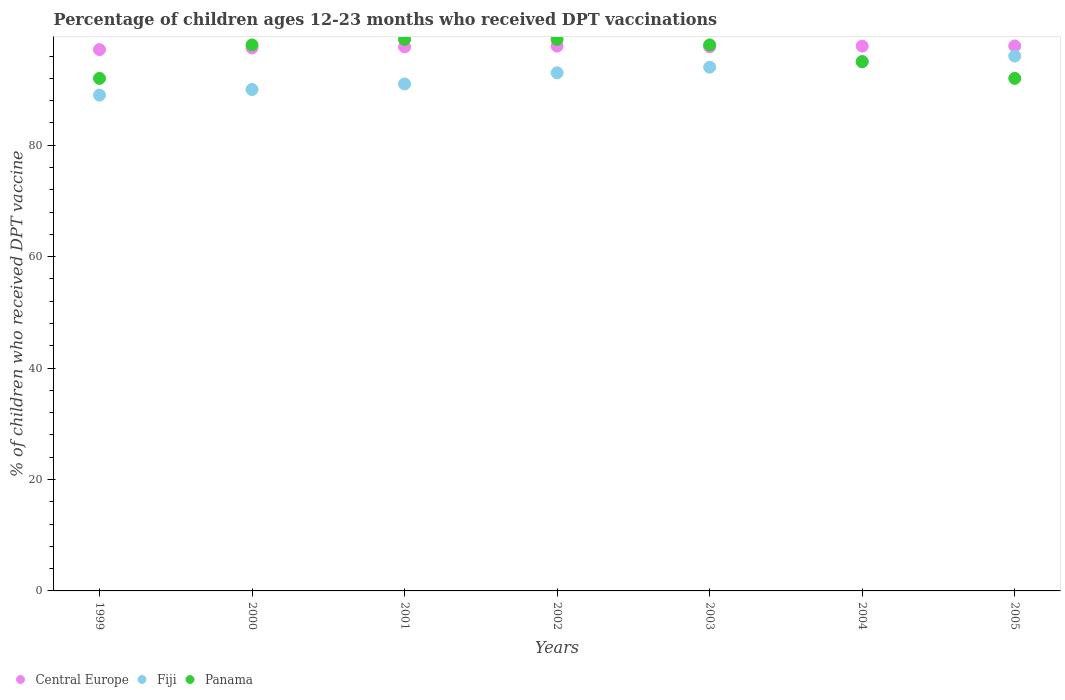How many different coloured dotlines are there?
Offer a terse response. 3. Is the number of dotlines equal to the number of legend labels?
Ensure brevity in your answer.  Yes. What is the percentage of children who received DPT vaccination in Panama in 2003?
Give a very brief answer. 98. Across all years, what is the maximum percentage of children who received DPT vaccination in Panama?
Your answer should be compact. 99. Across all years, what is the minimum percentage of children who received DPT vaccination in Panama?
Give a very brief answer. 92. In which year was the percentage of children who received DPT vaccination in Central Europe maximum?
Offer a terse response. 2005. In which year was the percentage of children who received DPT vaccination in Panama minimum?
Offer a very short reply. 1999. What is the total percentage of children who received DPT vaccination in Central Europe in the graph?
Provide a succinct answer. 683.32. What is the difference between the percentage of children who received DPT vaccination in Fiji in 2003 and that in 2005?
Offer a very short reply. -2. What is the difference between the percentage of children who received DPT vaccination in Panama in 2005 and the percentage of children who received DPT vaccination in Fiji in 2000?
Provide a short and direct response. 2. What is the average percentage of children who received DPT vaccination in Panama per year?
Give a very brief answer. 96.14. In the year 2002, what is the difference between the percentage of children who received DPT vaccination in Panama and percentage of children who received DPT vaccination in Fiji?
Your answer should be very brief. 6. What is the ratio of the percentage of children who received DPT vaccination in Central Europe in 1999 to that in 2004?
Your answer should be compact. 0.99. Is the percentage of children who received DPT vaccination in Panama in 2000 less than that in 2001?
Offer a very short reply. Yes. Is the difference between the percentage of children who received DPT vaccination in Panama in 2003 and 2004 greater than the difference between the percentage of children who received DPT vaccination in Fiji in 2003 and 2004?
Your answer should be compact. Yes. What is the difference between the highest and the lowest percentage of children who received DPT vaccination in Panama?
Ensure brevity in your answer.  7. Is the sum of the percentage of children who received DPT vaccination in Fiji in 2001 and 2004 greater than the maximum percentage of children who received DPT vaccination in Panama across all years?
Provide a short and direct response. Yes. Is it the case that in every year, the sum of the percentage of children who received DPT vaccination in Fiji and percentage of children who received DPT vaccination in Central Europe  is greater than the percentage of children who received DPT vaccination in Panama?
Your answer should be very brief. Yes. Does the percentage of children who received DPT vaccination in Panama monotonically increase over the years?
Ensure brevity in your answer.  No. How many dotlines are there?
Provide a short and direct response. 3. How many years are there in the graph?
Provide a short and direct response. 7. Are the values on the major ticks of Y-axis written in scientific E-notation?
Keep it short and to the point. No. Does the graph contain grids?
Offer a very short reply. No. How many legend labels are there?
Provide a short and direct response. 3. What is the title of the graph?
Give a very brief answer. Percentage of children ages 12-23 months who received DPT vaccinations. What is the label or title of the X-axis?
Your answer should be compact. Years. What is the label or title of the Y-axis?
Your answer should be very brief. % of children who received DPT vaccine. What is the % of children who received DPT vaccine of Central Europe in 1999?
Your answer should be very brief. 97.16. What is the % of children who received DPT vaccine in Fiji in 1999?
Offer a very short reply. 89. What is the % of children who received DPT vaccine of Panama in 1999?
Offer a terse response. 92. What is the % of children who received DPT vaccine of Central Europe in 2000?
Provide a short and direct response. 97.46. What is the % of children who received DPT vaccine of Fiji in 2000?
Offer a terse response. 90. What is the % of children who received DPT vaccine of Panama in 2000?
Keep it short and to the point. 98. What is the % of children who received DPT vaccine in Central Europe in 2001?
Make the answer very short. 97.65. What is the % of children who received DPT vaccine in Fiji in 2001?
Offer a terse response. 91. What is the % of children who received DPT vaccine of Central Europe in 2002?
Your answer should be very brief. 97.79. What is the % of children who received DPT vaccine of Fiji in 2002?
Keep it short and to the point. 93. What is the % of children who received DPT vaccine of Central Europe in 2003?
Offer a very short reply. 97.66. What is the % of children who received DPT vaccine in Fiji in 2003?
Your answer should be compact. 94. What is the % of children who received DPT vaccine of Panama in 2003?
Your answer should be compact. 98. What is the % of children who received DPT vaccine of Central Europe in 2004?
Make the answer very short. 97.79. What is the % of children who received DPT vaccine in Fiji in 2004?
Offer a terse response. 95. What is the % of children who received DPT vaccine in Central Europe in 2005?
Give a very brief answer. 97.81. What is the % of children who received DPT vaccine in Fiji in 2005?
Offer a terse response. 96. What is the % of children who received DPT vaccine in Panama in 2005?
Your answer should be compact. 92. Across all years, what is the maximum % of children who received DPT vaccine in Central Europe?
Make the answer very short. 97.81. Across all years, what is the maximum % of children who received DPT vaccine of Fiji?
Your answer should be very brief. 96. Across all years, what is the minimum % of children who received DPT vaccine in Central Europe?
Make the answer very short. 97.16. Across all years, what is the minimum % of children who received DPT vaccine of Fiji?
Your answer should be very brief. 89. Across all years, what is the minimum % of children who received DPT vaccine in Panama?
Provide a succinct answer. 92. What is the total % of children who received DPT vaccine in Central Europe in the graph?
Your answer should be compact. 683.32. What is the total % of children who received DPT vaccine of Fiji in the graph?
Provide a succinct answer. 648. What is the total % of children who received DPT vaccine in Panama in the graph?
Give a very brief answer. 673. What is the difference between the % of children who received DPT vaccine in Central Europe in 1999 and that in 2000?
Ensure brevity in your answer.  -0.3. What is the difference between the % of children who received DPT vaccine of Central Europe in 1999 and that in 2001?
Provide a succinct answer. -0.49. What is the difference between the % of children who received DPT vaccine in Fiji in 1999 and that in 2001?
Make the answer very short. -2. What is the difference between the % of children who received DPT vaccine in Panama in 1999 and that in 2001?
Give a very brief answer. -7. What is the difference between the % of children who received DPT vaccine in Central Europe in 1999 and that in 2002?
Offer a very short reply. -0.63. What is the difference between the % of children who received DPT vaccine of Panama in 1999 and that in 2002?
Your answer should be very brief. -7. What is the difference between the % of children who received DPT vaccine of Central Europe in 1999 and that in 2003?
Offer a terse response. -0.49. What is the difference between the % of children who received DPT vaccine in Fiji in 1999 and that in 2003?
Make the answer very short. -5. What is the difference between the % of children who received DPT vaccine in Panama in 1999 and that in 2003?
Ensure brevity in your answer.  -6. What is the difference between the % of children who received DPT vaccine of Central Europe in 1999 and that in 2004?
Your answer should be very brief. -0.62. What is the difference between the % of children who received DPT vaccine of Central Europe in 1999 and that in 2005?
Keep it short and to the point. -0.65. What is the difference between the % of children who received DPT vaccine of Central Europe in 2000 and that in 2001?
Your response must be concise. -0.19. What is the difference between the % of children who received DPT vaccine of Fiji in 2000 and that in 2001?
Ensure brevity in your answer.  -1. What is the difference between the % of children who received DPT vaccine in Central Europe in 2000 and that in 2002?
Give a very brief answer. -0.33. What is the difference between the % of children who received DPT vaccine in Fiji in 2000 and that in 2002?
Give a very brief answer. -3. What is the difference between the % of children who received DPT vaccine of Central Europe in 2000 and that in 2003?
Offer a very short reply. -0.19. What is the difference between the % of children who received DPT vaccine of Panama in 2000 and that in 2003?
Your response must be concise. 0. What is the difference between the % of children who received DPT vaccine of Central Europe in 2000 and that in 2004?
Keep it short and to the point. -0.32. What is the difference between the % of children who received DPT vaccine in Fiji in 2000 and that in 2004?
Make the answer very short. -5. What is the difference between the % of children who received DPT vaccine in Central Europe in 2000 and that in 2005?
Your answer should be compact. -0.35. What is the difference between the % of children who received DPT vaccine of Fiji in 2000 and that in 2005?
Offer a very short reply. -6. What is the difference between the % of children who received DPT vaccine in Central Europe in 2001 and that in 2002?
Make the answer very short. -0.14. What is the difference between the % of children who received DPT vaccine in Fiji in 2001 and that in 2002?
Your answer should be compact. -2. What is the difference between the % of children who received DPT vaccine in Panama in 2001 and that in 2002?
Ensure brevity in your answer.  0. What is the difference between the % of children who received DPT vaccine of Central Europe in 2001 and that in 2003?
Your answer should be very brief. -0.01. What is the difference between the % of children who received DPT vaccine of Central Europe in 2001 and that in 2004?
Your response must be concise. -0.13. What is the difference between the % of children who received DPT vaccine of Fiji in 2001 and that in 2004?
Offer a very short reply. -4. What is the difference between the % of children who received DPT vaccine of Panama in 2001 and that in 2004?
Ensure brevity in your answer.  4. What is the difference between the % of children who received DPT vaccine in Central Europe in 2001 and that in 2005?
Offer a terse response. -0.16. What is the difference between the % of children who received DPT vaccine of Fiji in 2001 and that in 2005?
Keep it short and to the point. -5. What is the difference between the % of children who received DPT vaccine in Central Europe in 2002 and that in 2003?
Offer a terse response. 0.13. What is the difference between the % of children who received DPT vaccine in Fiji in 2002 and that in 2003?
Provide a succinct answer. -1. What is the difference between the % of children who received DPT vaccine in Central Europe in 2002 and that in 2004?
Ensure brevity in your answer.  0.01. What is the difference between the % of children who received DPT vaccine of Fiji in 2002 and that in 2004?
Your response must be concise. -2. What is the difference between the % of children who received DPT vaccine in Panama in 2002 and that in 2004?
Keep it short and to the point. 4. What is the difference between the % of children who received DPT vaccine of Central Europe in 2002 and that in 2005?
Your answer should be very brief. -0.02. What is the difference between the % of children who received DPT vaccine of Fiji in 2002 and that in 2005?
Make the answer very short. -3. What is the difference between the % of children who received DPT vaccine of Panama in 2002 and that in 2005?
Your answer should be very brief. 7. What is the difference between the % of children who received DPT vaccine in Central Europe in 2003 and that in 2004?
Give a very brief answer. -0.13. What is the difference between the % of children who received DPT vaccine of Fiji in 2003 and that in 2004?
Offer a terse response. -1. What is the difference between the % of children who received DPT vaccine in Panama in 2003 and that in 2004?
Keep it short and to the point. 3. What is the difference between the % of children who received DPT vaccine of Central Europe in 2003 and that in 2005?
Your response must be concise. -0.15. What is the difference between the % of children who received DPT vaccine in Fiji in 2003 and that in 2005?
Make the answer very short. -2. What is the difference between the % of children who received DPT vaccine of Panama in 2003 and that in 2005?
Make the answer very short. 6. What is the difference between the % of children who received DPT vaccine in Central Europe in 2004 and that in 2005?
Your response must be concise. -0.02. What is the difference between the % of children who received DPT vaccine in Fiji in 2004 and that in 2005?
Keep it short and to the point. -1. What is the difference between the % of children who received DPT vaccine in Central Europe in 1999 and the % of children who received DPT vaccine in Fiji in 2000?
Keep it short and to the point. 7.16. What is the difference between the % of children who received DPT vaccine of Central Europe in 1999 and the % of children who received DPT vaccine of Panama in 2000?
Provide a succinct answer. -0.84. What is the difference between the % of children who received DPT vaccine of Fiji in 1999 and the % of children who received DPT vaccine of Panama in 2000?
Your response must be concise. -9. What is the difference between the % of children who received DPT vaccine in Central Europe in 1999 and the % of children who received DPT vaccine in Fiji in 2001?
Your answer should be compact. 6.16. What is the difference between the % of children who received DPT vaccine of Central Europe in 1999 and the % of children who received DPT vaccine of Panama in 2001?
Offer a very short reply. -1.84. What is the difference between the % of children who received DPT vaccine in Central Europe in 1999 and the % of children who received DPT vaccine in Fiji in 2002?
Ensure brevity in your answer.  4.16. What is the difference between the % of children who received DPT vaccine in Central Europe in 1999 and the % of children who received DPT vaccine in Panama in 2002?
Give a very brief answer. -1.84. What is the difference between the % of children who received DPT vaccine in Fiji in 1999 and the % of children who received DPT vaccine in Panama in 2002?
Your answer should be compact. -10. What is the difference between the % of children who received DPT vaccine in Central Europe in 1999 and the % of children who received DPT vaccine in Fiji in 2003?
Your answer should be compact. 3.16. What is the difference between the % of children who received DPT vaccine in Central Europe in 1999 and the % of children who received DPT vaccine in Panama in 2003?
Offer a terse response. -0.84. What is the difference between the % of children who received DPT vaccine in Central Europe in 1999 and the % of children who received DPT vaccine in Fiji in 2004?
Ensure brevity in your answer.  2.16. What is the difference between the % of children who received DPT vaccine of Central Europe in 1999 and the % of children who received DPT vaccine of Panama in 2004?
Your answer should be compact. 2.16. What is the difference between the % of children who received DPT vaccine of Fiji in 1999 and the % of children who received DPT vaccine of Panama in 2004?
Keep it short and to the point. -6. What is the difference between the % of children who received DPT vaccine in Central Europe in 1999 and the % of children who received DPT vaccine in Fiji in 2005?
Offer a very short reply. 1.16. What is the difference between the % of children who received DPT vaccine of Central Europe in 1999 and the % of children who received DPT vaccine of Panama in 2005?
Offer a terse response. 5.16. What is the difference between the % of children who received DPT vaccine of Fiji in 1999 and the % of children who received DPT vaccine of Panama in 2005?
Offer a very short reply. -3. What is the difference between the % of children who received DPT vaccine of Central Europe in 2000 and the % of children who received DPT vaccine of Fiji in 2001?
Your response must be concise. 6.46. What is the difference between the % of children who received DPT vaccine in Central Europe in 2000 and the % of children who received DPT vaccine in Panama in 2001?
Your answer should be compact. -1.54. What is the difference between the % of children who received DPT vaccine of Fiji in 2000 and the % of children who received DPT vaccine of Panama in 2001?
Provide a succinct answer. -9. What is the difference between the % of children who received DPT vaccine of Central Europe in 2000 and the % of children who received DPT vaccine of Fiji in 2002?
Provide a succinct answer. 4.46. What is the difference between the % of children who received DPT vaccine in Central Europe in 2000 and the % of children who received DPT vaccine in Panama in 2002?
Ensure brevity in your answer.  -1.54. What is the difference between the % of children who received DPT vaccine in Central Europe in 2000 and the % of children who received DPT vaccine in Fiji in 2003?
Provide a short and direct response. 3.46. What is the difference between the % of children who received DPT vaccine of Central Europe in 2000 and the % of children who received DPT vaccine of Panama in 2003?
Your response must be concise. -0.54. What is the difference between the % of children who received DPT vaccine in Central Europe in 2000 and the % of children who received DPT vaccine in Fiji in 2004?
Your response must be concise. 2.46. What is the difference between the % of children who received DPT vaccine of Central Europe in 2000 and the % of children who received DPT vaccine of Panama in 2004?
Give a very brief answer. 2.46. What is the difference between the % of children who received DPT vaccine of Fiji in 2000 and the % of children who received DPT vaccine of Panama in 2004?
Provide a short and direct response. -5. What is the difference between the % of children who received DPT vaccine of Central Europe in 2000 and the % of children who received DPT vaccine of Fiji in 2005?
Give a very brief answer. 1.46. What is the difference between the % of children who received DPT vaccine of Central Europe in 2000 and the % of children who received DPT vaccine of Panama in 2005?
Ensure brevity in your answer.  5.46. What is the difference between the % of children who received DPT vaccine in Central Europe in 2001 and the % of children who received DPT vaccine in Fiji in 2002?
Offer a terse response. 4.65. What is the difference between the % of children who received DPT vaccine of Central Europe in 2001 and the % of children who received DPT vaccine of Panama in 2002?
Provide a succinct answer. -1.35. What is the difference between the % of children who received DPT vaccine of Central Europe in 2001 and the % of children who received DPT vaccine of Fiji in 2003?
Your answer should be compact. 3.65. What is the difference between the % of children who received DPT vaccine in Central Europe in 2001 and the % of children who received DPT vaccine in Panama in 2003?
Provide a short and direct response. -0.35. What is the difference between the % of children who received DPT vaccine of Central Europe in 2001 and the % of children who received DPT vaccine of Fiji in 2004?
Your response must be concise. 2.65. What is the difference between the % of children who received DPT vaccine in Central Europe in 2001 and the % of children who received DPT vaccine in Panama in 2004?
Your answer should be compact. 2.65. What is the difference between the % of children who received DPT vaccine in Central Europe in 2001 and the % of children who received DPT vaccine in Fiji in 2005?
Make the answer very short. 1.65. What is the difference between the % of children who received DPT vaccine in Central Europe in 2001 and the % of children who received DPT vaccine in Panama in 2005?
Your answer should be compact. 5.65. What is the difference between the % of children who received DPT vaccine in Fiji in 2001 and the % of children who received DPT vaccine in Panama in 2005?
Keep it short and to the point. -1. What is the difference between the % of children who received DPT vaccine of Central Europe in 2002 and the % of children who received DPT vaccine of Fiji in 2003?
Provide a short and direct response. 3.79. What is the difference between the % of children who received DPT vaccine in Central Europe in 2002 and the % of children who received DPT vaccine in Panama in 2003?
Keep it short and to the point. -0.21. What is the difference between the % of children who received DPT vaccine in Fiji in 2002 and the % of children who received DPT vaccine in Panama in 2003?
Give a very brief answer. -5. What is the difference between the % of children who received DPT vaccine in Central Europe in 2002 and the % of children who received DPT vaccine in Fiji in 2004?
Offer a terse response. 2.79. What is the difference between the % of children who received DPT vaccine of Central Europe in 2002 and the % of children who received DPT vaccine of Panama in 2004?
Ensure brevity in your answer.  2.79. What is the difference between the % of children who received DPT vaccine of Central Europe in 2002 and the % of children who received DPT vaccine of Fiji in 2005?
Your answer should be very brief. 1.79. What is the difference between the % of children who received DPT vaccine in Central Europe in 2002 and the % of children who received DPT vaccine in Panama in 2005?
Your answer should be compact. 5.79. What is the difference between the % of children who received DPT vaccine in Fiji in 2002 and the % of children who received DPT vaccine in Panama in 2005?
Keep it short and to the point. 1. What is the difference between the % of children who received DPT vaccine in Central Europe in 2003 and the % of children who received DPT vaccine in Fiji in 2004?
Keep it short and to the point. 2.66. What is the difference between the % of children who received DPT vaccine in Central Europe in 2003 and the % of children who received DPT vaccine in Panama in 2004?
Give a very brief answer. 2.66. What is the difference between the % of children who received DPT vaccine in Central Europe in 2003 and the % of children who received DPT vaccine in Fiji in 2005?
Provide a short and direct response. 1.66. What is the difference between the % of children who received DPT vaccine in Central Europe in 2003 and the % of children who received DPT vaccine in Panama in 2005?
Your answer should be compact. 5.66. What is the difference between the % of children who received DPT vaccine in Central Europe in 2004 and the % of children who received DPT vaccine in Fiji in 2005?
Provide a succinct answer. 1.79. What is the difference between the % of children who received DPT vaccine of Central Europe in 2004 and the % of children who received DPT vaccine of Panama in 2005?
Offer a very short reply. 5.79. What is the difference between the % of children who received DPT vaccine of Fiji in 2004 and the % of children who received DPT vaccine of Panama in 2005?
Your response must be concise. 3. What is the average % of children who received DPT vaccine in Central Europe per year?
Make the answer very short. 97.62. What is the average % of children who received DPT vaccine of Fiji per year?
Your answer should be very brief. 92.57. What is the average % of children who received DPT vaccine of Panama per year?
Ensure brevity in your answer.  96.14. In the year 1999, what is the difference between the % of children who received DPT vaccine of Central Europe and % of children who received DPT vaccine of Fiji?
Offer a terse response. 8.16. In the year 1999, what is the difference between the % of children who received DPT vaccine of Central Europe and % of children who received DPT vaccine of Panama?
Provide a short and direct response. 5.16. In the year 1999, what is the difference between the % of children who received DPT vaccine in Fiji and % of children who received DPT vaccine in Panama?
Your response must be concise. -3. In the year 2000, what is the difference between the % of children who received DPT vaccine of Central Europe and % of children who received DPT vaccine of Fiji?
Keep it short and to the point. 7.46. In the year 2000, what is the difference between the % of children who received DPT vaccine of Central Europe and % of children who received DPT vaccine of Panama?
Keep it short and to the point. -0.54. In the year 2000, what is the difference between the % of children who received DPT vaccine in Fiji and % of children who received DPT vaccine in Panama?
Make the answer very short. -8. In the year 2001, what is the difference between the % of children who received DPT vaccine in Central Europe and % of children who received DPT vaccine in Fiji?
Make the answer very short. 6.65. In the year 2001, what is the difference between the % of children who received DPT vaccine in Central Europe and % of children who received DPT vaccine in Panama?
Offer a very short reply. -1.35. In the year 2002, what is the difference between the % of children who received DPT vaccine of Central Europe and % of children who received DPT vaccine of Fiji?
Your answer should be compact. 4.79. In the year 2002, what is the difference between the % of children who received DPT vaccine of Central Europe and % of children who received DPT vaccine of Panama?
Offer a very short reply. -1.21. In the year 2002, what is the difference between the % of children who received DPT vaccine in Fiji and % of children who received DPT vaccine in Panama?
Your answer should be compact. -6. In the year 2003, what is the difference between the % of children who received DPT vaccine in Central Europe and % of children who received DPT vaccine in Fiji?
Ensure brevity in your answer.  3.66. In the year 2003, what is the difference between the % of children who received DPT vaccine of Central Europe and % of children who received DPT vaccine of Panama?
Keep it short and to the point. -0.34. In the year 2004, what is the difference between the % of children who received DPT vaccine in Central Europe and % of children who received DPT vaccine in Fiji?
Provide a succinct answer. 2.79. In the year 2004, what is the difference between the % of children who received DPT vaccine in Central Europe and % of children who received DPT vaccine in Panama?
Ensure brevity in your answer.  2.79. In the year 2004, what is the difference between the % of children who received DPT vaccine in Fiji and % of children who received DPT vaccine in Panama?
Your answer should be very brief. 0. In the year 2005, what is the difference between the % of children who received DPT vaccine of Central Europe and % of children who received DPT vaccine of Fiji?
Ensure brevity in your answer.  1.81. In the year 2005, what is the difference between the % of children who received DPT vaccine of Central Europe and % of children who received DPT vaccine of Panama?
Keep it short and to the point. 5.81. What is the ratio of the % of children who received DPT vaccine of Central Europe in 1999 to that in 2000?
Offer a very short reply. 1. What is the ratio of the % of children who received DPT vaccine of Fiji in 1999 to that in 2000?
Your response must be concise. 0.99. What is the ratio of the % of children who received DPT vaccine of Panama in 1999 to that in 2000?
Offer a very short reply. 0.94. What is the ratio of the % of children who received DPT vaccine of Fiji in 1999 to that in 2001?
Your response must be concise. 0.98. What is the ratio of the % of children who received DPT vaccine in Panama in 1999 to that in 2001?
Keep it short and to the point. 0.93. What is the ratio of the % of children who received DPT vaccine in Panama in 1999 to that in 2002?
Provide a succinct answer. 0.93. What is the ratio of the % of children who received DPT vaccine in Central Europe in 1999 to that in 2003?
Ensure brevity in your answer.  0.99. What is the ratio of the % of children who received DPT vaccine in Fiji in 1999 to that in 2003?
Your answer should be very brief. 0.95. What is the ratio of the % of children who received DPT vaccine in Panama in 1999 to that in 2003?
Your response must be concise. 0.94. What is the ratio of the % of children who received DPT vaccine of Central Europe in 1999 to that in 2004?
Offer a very short reply. 0.99. What is the ratio of the % of children who received DPT vaccine in Fiji in 1999 to that in 2004?
Make the answer very short. 0.94. What is the ratio of the % of children who received DPT vaccine of Panama in 1999 to that in 2004?
Ensure brevity in your answer.  0.97. What is the ratio of the % of children who received DPT vaccine in Central Europe in 1999 to that in 2005?
Provide a short and direct response. 0.99. What is the ratio of the % of children who received DPT vaccine in Fiji in 1999 to that in 2005?
Your response must be concise. 0.93. What is the ratio of the % of children who received DPT vaccine of Central Europe in 2000 to that in 2001?
Give a very brief answer. 1. What is the ratio of the % of children who received DPT vaccine in Fiji in 2000 to that in 2001?
Offer a very short reply. 0.99. What is the ratio of the % of children who received DPT vaccine in Central Europe in 2000 to that in 2002?
Keep it short and to the point. 1. What is the ratio of the % of children who received DPT vaccine of Panama in 2000 to that in 2002?
Provide a succinct answer. 0.99. What is the ratio of the % of children who received DPT vaccine in Central Europe in 2000 to that in 2003?
Your response must be concise. 1. What is the ratio of the % of children who received DPT vaccine in Fiji in 2000 to that in 2003?
Ensure brevity in your answer.  0.96. What is the ratio of the % of children who received DPT vaccine in Panama in 2000 to that in 2003?
Keep it short and to the point. 1. What is the ratio of the % of children who received DPT vaccine of Central Europe in 2000 to that in 2004?
Provide a succinct answer. 1. What is the ratio of the % of children who received DPT vaccine of Panama in 2000 to that in 2004?
Make the answer very short. 1.03. What is the ratio of the % of children who received DPT vaccine of Fiji in 2000 to that in 2005?
Keep it short and to the point. 0.94. What is the ratio of the % of children who received DPT vaccine of Panama in 2000 to that in 2005?
Keep it short and to the point. 1.07. What is the ratio of the % of children who received DPT vaccine of Fiji in 2001 to that in 2002?
Provide a short and direct response. 0.98. What is the ratio of the % of children who received DPT vaccine of Central Europe in 2001 to that in 2003?
Provide a succinct answer. 1. What is the ratio of the % of children who received DPT vaccine of Fiji in 2001 to that in 2003?
Your answer should be very brief. 0.97. What is the ratio of the % of children who received DPT vaccine in Panama in 2001 to that in 2003?
Your answer should be very brief. 1.01. What is the ratio of the % of children who received DPT vaccine in Fiji in 2001 to that in 2004?
Keep it short and to the point. 0.96. What is the ratio of the % of children who received DPT vaccine of Panama in 2001 to that in 2004?
Make the answer very short. 1.04. What is the ratio of the % of children who received DPT vaccine of Central Europe in 2001 to that in 2005?
Your answer should be very brief. 1. What is the ratio of the % of children who received DPT vaccine in Fiji in 2001 to that in 2005?
Ensure brevity in your answer.  0.95. What is the ratio of the % of children who received DPT vaccine of Panama in 2001 to that in 2005?
Your response must be concise. 1.08. What is the ratio of the % of children who received DPT vaccine in Fiji in 2002 to that in 2003?
Make the answer very short. 0.99. What is the ratio of the % of children who received DPT vaccine of Panama in 2002 to that in 2003?
Offer a terse response. 1.01. What is the ratio of the % of children who received DPT vaccine of Central Europe in 2002 to that in 2004?
Ensure brevity in your answer.  1. What is the ratio of the % of children who received DPT vaccine in Fiji in 2002 to that in 2004?
Give a very brief answer. 0.98. What is the ratio of the % of children who received DPT vaccine in Panama in 2002 to that in 2004?
Offer a very short reply. 1.04. What is the ratio of the % of children who received DPT vaccine in Fiji in 2002 to that in 2005?
Provide a short and direct response. 0.97. What is the ratio of the % of children who received DPT vaccine of Panama in 2002 to that in 2005?
Give a very brief answer. 1.08. What is the ratio of the % of children who received DPT vaccine of Fiji in 2003 to that in 2004?
Offer a very short reply. 0.99. What is the ratio of the % of children who received DPT vaccine in Panama in 2003 to that in 2004?
Offer a terse response. 1.03. What is the ratio of the % of children who received DPT vaccine of Fiji in 2003 to that in 2005?
Ensure brevity in your answer.  0.98. What is the ratio of the % of children who received DPT vaccine in Panama in 2003 to that in 2005?
Keep it short and to the point. 1.07. What is the ratio of the % of children who received DPT vaccine in Central Europe in 2004 to that in 2005?
Offer a terse response. 1. What is the ratio of the % of children who received DPT vaccine in Fiji in 2004 to that in 2005?
Your answer should be compact. 0.99. What is the ratio of the % of children who received DPT vaccine of Panama in 2004 to that in 2005?
Offer a terse response. 1.03. What is the difference between the highest and the second highest % of children who received DPT vaccine in Central Europe?
Your response must be concise. 0.02. What is the difference between the highest and the second highest % of children who received DPT vaccine in Fiji?
Ensure brevity in your answer.  1. What is the difference between the highest and the second highest % of children who received DPT vaccine in Panama?
Make the answer very short. 0. What is the difference between the highest and the lowest % of children who received DPT vaccine in Central Europe?
Your response must be concise. 0.65. What is the difference between the highest and the lowest % of children who received DPT vaccine in Fiji?
Your answer should be compact. 7. 